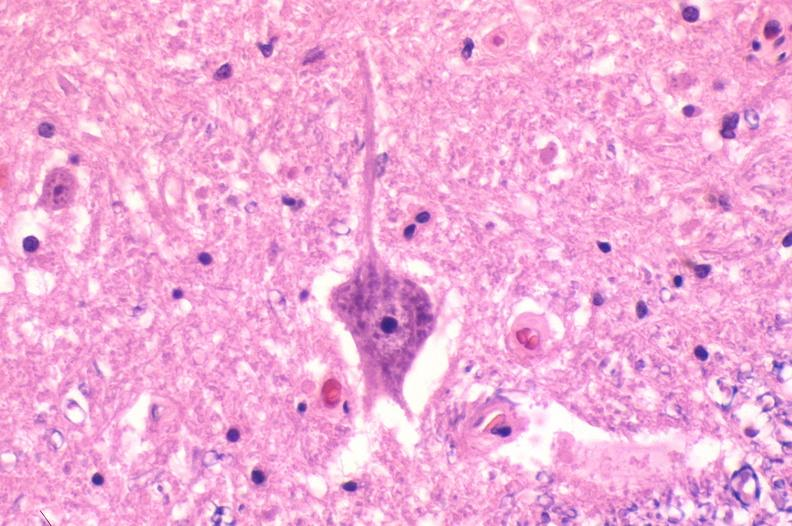s basal skull fracture present?
Answer the question using a single word or phrase. No 